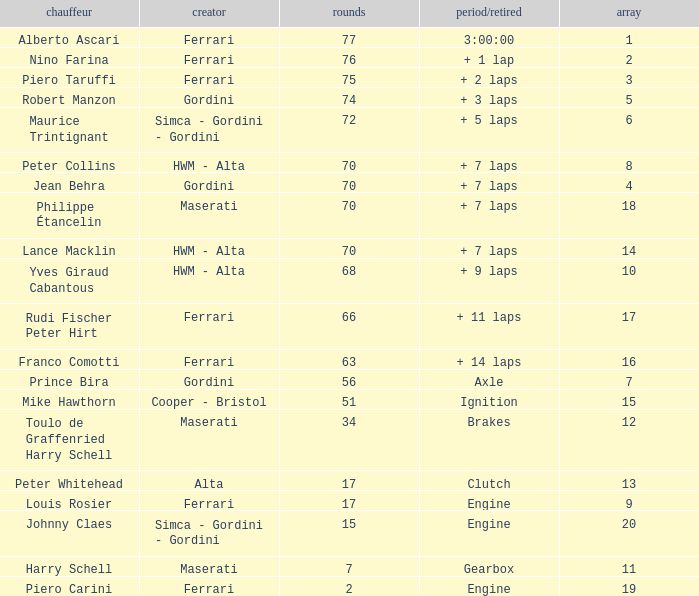What is the high grid for ferrari's with 2 laps? 19.0. 